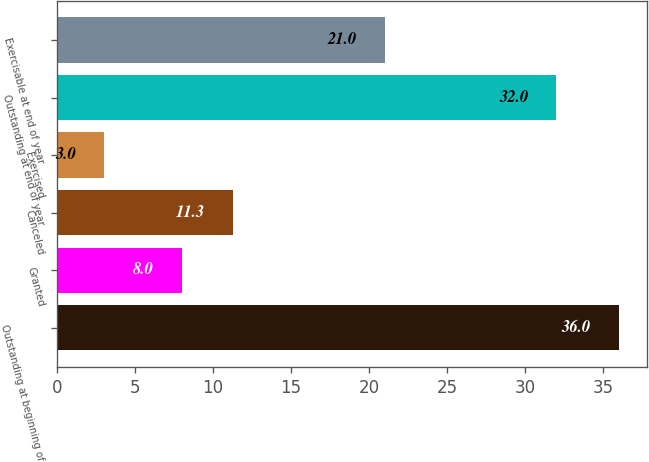Convert chart to OTSL. <chart><loc_0><loc_0><loc_500><loc_500><bar_chart><fcel>Outstanding at beginning of<fcel>Granted<fcel>Canceled<fcel>Exercised<fcel>Outstanding at end of year<fcel>Exercisable at end of year<nl><fcel>36<fcel>8<fcel>11.3<fcel>3<fcel>32<fcel>21<nl></chart> 